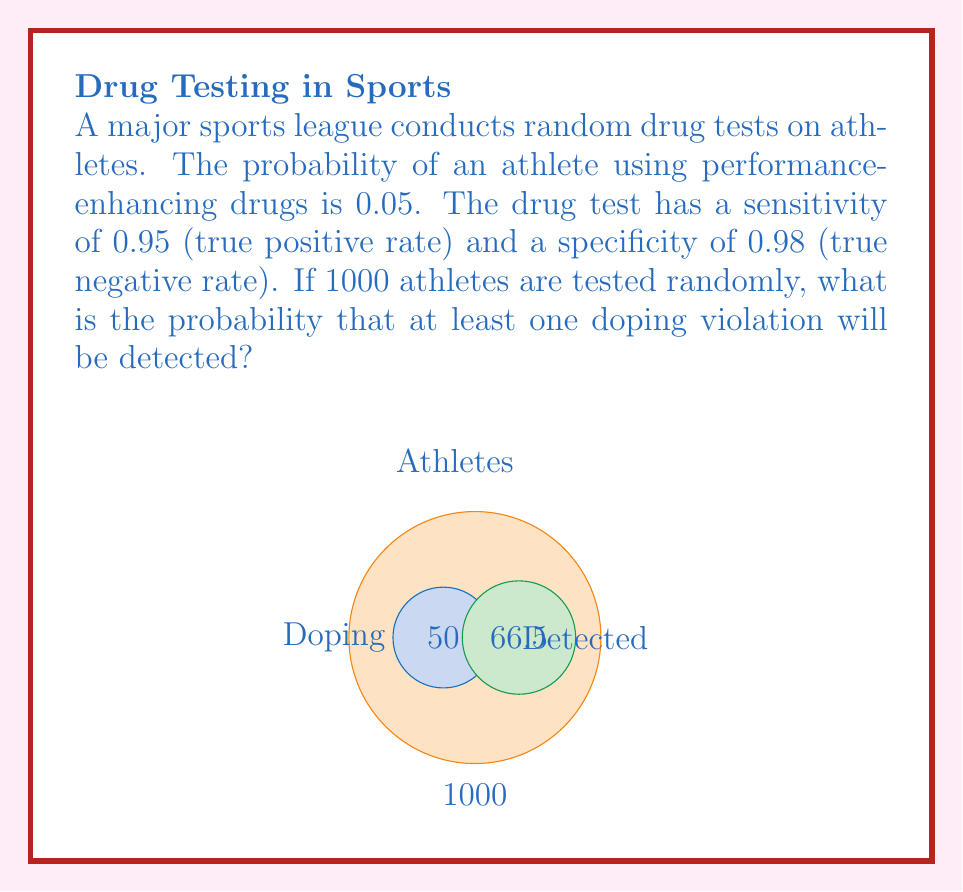Solve this math problem. Let's approach this step-by-step:

1) First, we need to calculate the probability of detecting a doping violation in a single test.

2) The probability of detecting a doping violation is the sum of:
   a) The probability of correctly identifying a doper (true positive)
   b) The probability of incorrectly identifying a non-doper (false positive)

3) Let's calculate each:
   a) P(true positive) = P(doping) * sensitivity = 0.05 * 0.95 = 0.0475
   b) P(false positive) = P(not doping) * (1 - specificity) = 0.95 * (1 - 0.98) = 0.019

4) The total probability of a positive test result is:
   P(positive test) = 0.0475 + 0.019 = 0.0665

5) Now, we need to find the probability of at least one positive result in 1000 tests.

6) It's easier to calculate the probability of no positive results and then subtract from 1:
   P(at least one positive) = 1 - P(no positives)

7) The probability of no positives in 1000 tests is:
   P(no positives) = (1 - 0.0665)^1000

8) Therefore, the probability of at least one positive is:
   P(at least one positive) = 1 - (1 - 0.0665)^1000

9) Calculating this:
   $$1 - (1 - 0.0665)^{1000} \approx 0.999999999999999999999999999995$$
Answer: $\approx 1$ (effectively certain) 